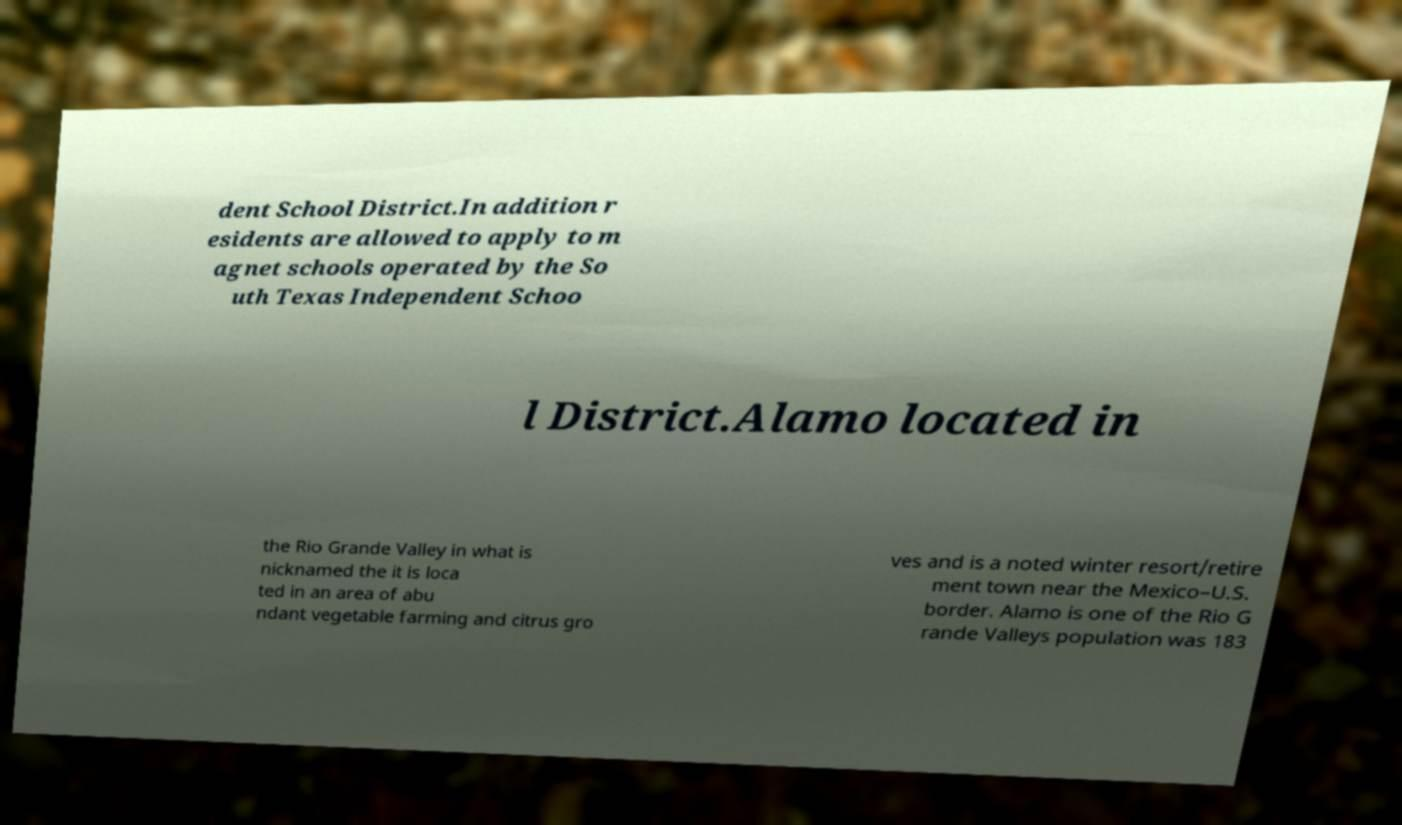Please read and relay the text visible in this image. What does it say? dent School District.In addition r esidents are allowed to apply to m agnet schools operated by the So uth Texas Independent Schoo l District.Alamo located in the Rio Grande Valley in what is nicknamed the it is loca ted in an area of abu ndant vegetable farming and citrus gro ves and is a noted winter resort/retire ment town near the Mexico–U.S. border. Alamo is one of the Rio G rande Valleys population was 183 